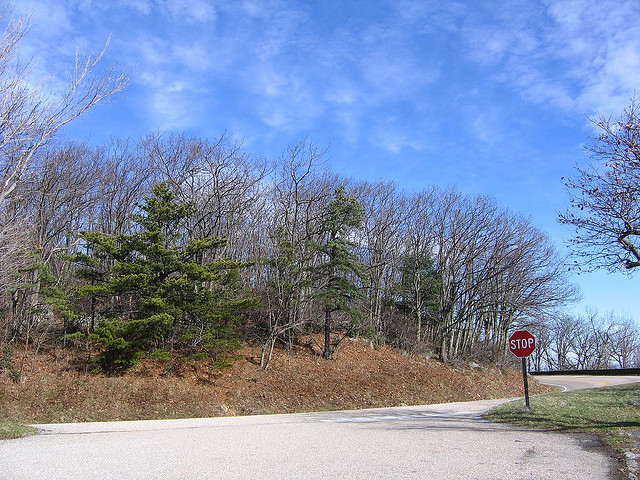What does the street sign say? The street sign clearly displays 'STOP,' indicating a stop sign at the road intersection. 